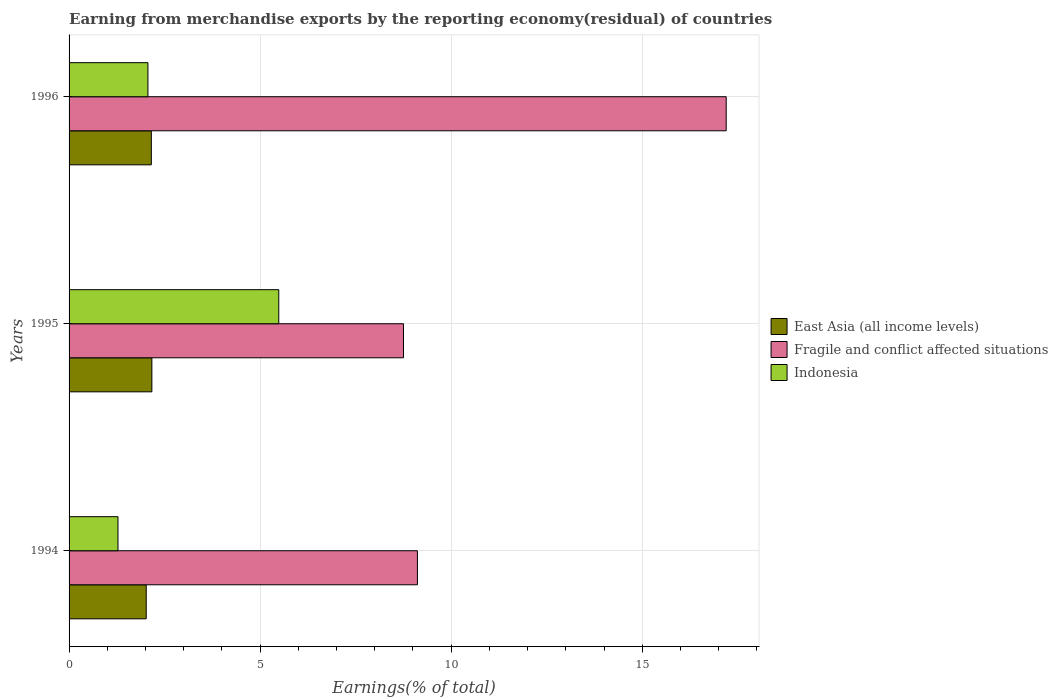How many groups of bars are there?
Make the answer very short. 3. Are the number of bars on each tick of the Y-axis equal?
Keep it short and to the point. Yes. How many bars are there on the 1st tick from the top?
Your answer should be compact. 3. How many bars are there on the 3rd tick from the bottom?
Make the answer very short. 3. What is the label of the 3rd group of bars from the top?
Provide a succinct answer. 1994. In how many cases, is the number of bars for a given year not equal to the number of legend labels?
Offer a very short reply. 0. What is the percentage of amount earned from merchandise exports in Indonesia in 1996?
Your answer should be compact. 2.06. Across all years, what is the maximum percentage of amount earned from merchandise exports in Fragile and conflict affected situations?
Your answer should be very brief. 17.2. Across all years, what is the minimum percentage of amount earned from merchandise exports in East Asia (all income levels)?
Provide a succinct answer. 2.02. In which year was the percentage of amount earned from merchandise exports in Fragile and conflict affected situations maximum?
Ensure brevity in your answer.  1996. What is the total percentage of amount earned from merchandise exports in East Asia (all income levels) in the graph?
Offer a very short reply. 6.34. What is the difference between the percentage of amount earned from merchandise exports in Fragile and conflict affected situations in 1995 and that in 1996?
Your response must be concise. -8.45. What is the difference between the percentage of amount earned from merchandise exports in Fragile and conflict affected situations in 1994 and the percentage of amount earned from merchandise exports in East Asia (all income levels) in 1995?
Offer a terse response. 6.95. What is the average percentage of amount earned from merchandise exports in Indonesia per year?
Your answer should be very brief. 2.94. In the year 1995, what is the difference between the percentage of amount earned from merchandise exports in East Asia (all income levels) and percentage of amount earned from merchandise exports in Fragile and conflict affected situations?
Provide a succinct answer. -6.59. What is the ratio of the percentage of amount earned from merchandise exports in East Asia (all income levels) in 1994 to that in 1996?
Make the answer very short. 0.94. Is the percentage of amount earned from merchandise exports in Fragile and conflict affected situations in 1994 less than that in 1995?
Offer a terse response. No. What is the difference between the highest and the second highest percentage of amount earned from merchandise exports in Indonesia?
Make the answer very short. 3.42. What is the difference between the highest and the lowest percentage of amount earned from merchandise exports in East Asia (all income levels)?
Your response must be concise. 0.15. In how many years, is the percentage of amount earned from merchandise exports in Fragile and conflict affected situations greater than the average percentage of amount earned from merchandise exports in Fragile and conflict affected situations taken over all years?
Keep it short and to the point. 1. What does the 2nd bar from the top in 1994 represents?
Provide a succinct answer. Fragile and conflict affected situations. What does the 1st bar from the bottom in 1995 represents?
Provide a succinct answer. East Asia (all income levels). How many bars are there?
Offer a very short reply. 9. Are the values on the major ticks of X-axis written in scientific E-notation?
Your response must be concise. No. Does the graph contain grids?
Provide a short and direct response. Yes. How many legend labels are there?
Your response must be concise. 3. What is the title of the graph?
Your answer should be very brief. Earning from merchandise exports by the reporting economy(residual) of countries. What is the label or title of the X-axis?
Offer a very short reply. Earnings(% of total). What is the Earnings(% of total) in East Asia (all income levels) in 1994?
Make the answer very short. 2.02. What is the Earnings(% of total) in Fragile and conflict affected situations in 1994?
Ensure brevity in your answer.  9.12. What is the Earnings(% of total) in Indonesia in 1994?
Provide a short and direct response. 1.28. What is the Earnings(% of total) of East Asia (all income levels) in 1995?
Give a very brief answer. 2.17. What is the Earnings(% of total) in Fragile and conflict affected situations in 1995?
Your response must be concise. 8.75. What is the Earnings(% of total) in Indonesia in 1995?
Provide a short and direct response. 5.49. What is the Earnings(% of total) in East Asia (all income levels) in 1996?
Offer a very short reply. 2.15. What is the Earnings(% of total) in Fragile and conflict affected situations in 1996?
Your answer should be compact. 17.2. What is the Earnings(% of total) in Indonesia in 1996?
Keep it short and to the point. 2.06. Across all years, what is the maximum Earnings(% of total) of East Asia (all income levels)?
Your answer should be compact. 2.17. Across all years, what is the maximum Earnings(% of total) of Fragile and conflict affected situations?
Offer a very short reply. 17.2. Across all years, what is the maximum Earnings(% of total) in Indonesia?
Keep it short and to the point. 5.49. Across all years, what is the minimum Earnings(% of total) of East Asia (all income levels)?
Make the answer very short. 2.02. Across all years, what is the minimum Earnings(% of total) in Fragile and conflict affected situations?
Make the answer very short. 8.75. Across all years, what is the minimum Earnings(% of total) in Indonesia?
Give a very brief answer. 1.28. What is the total Earnings(% of total) in East Asia (all income levels) in the graph?
Offer a very short reply. 6.34. What is the total Earnings(% of total) of Fragile and conflict affected situations in the graph?
Ensure brevity in your answer.  35.07. What is the total Earnings(% of total) of Indonesia in the graph?
Keep it short and to the point. 8.83. What is the difference between the Earnings(% of total) in East Asia (all income levels) in 1994 and that in 1995?
Ensure brevity in your answer.  -0.15. What is the difference between the Earnings(% of total) in Fragile and conflict affected situations in 1994 and that in 1995?
Offer a terse response. 0.36. What is the difference between the Earnings(% of total) of Indonesia in 1994 and that in 1995?
Offer a very short reply. -4.21. What is the difference between the Earnings(% of total) in East Asia (all income levels) in 1994 and that in 1996?
Keep it short and to the point. -0.13. What is the difference between the Earnings(% of total) of Fragile and conflict affected situations in 1994 and that in 1996?
Give a very brief answer. -8.08. What is the difference between the Earnings(% of total) in Indonesia in 1994 and that in 1996?
Keep it short and to the point. -0.78. What is the difference between the Earnings(% of total) in East Asia (all income levels) in 1995 and that in 1996?
Your answer should be very brief. 0.01. What is the difference between the Earnings(% of total) of Fragile and conflict affected situations in 1995 and that in 1996?
Your answer should be compact. -8.45. What is the difference between the Earnings(% of total) of Indonesia in 1995 and that in 1996?
Provide a succinct answer. 3.42. What is the difference between the Earnings(% of total) of East Asia (all income levels) in 1994 and the Earnings(% of total) of Fragile and conflict affected situations in 1995?
Make the answer very short. -6.73. What is the difference between the Earnings(% of total) in East Asia (all income levels) in 1994 and the Earnings(% of total) in Indonesia in 1995?
Your answer should be very brief. -3.47. What is the difference between the Earnings(% of total) in Fragile and conflict affected situations in 1994 and the Earnings(% of total) in Indonesia in 1995?
Your answer should be very brief. 3.63. What is the difference between the Earnings(% of total) of East Asia (all income levels) in 1994 and the Earnings(% of total) of Fragile and conflict affected situations in 1996?
Provide a succinct answer. -15.18. What is the difference between the Earnings(% of total) in East Asia (all income levels) in 1994 and the Earnings(% of total) in Indonesia in 1996?
Ensure brevity in your answer.  -0.04. What is the difference between the Earnings(% of total) of Fragile and conflict affected situations in 1994 and the Earnings(% of total) of Indonesia in 1996?
Offer a very short reply. 7.05. What is the difference between the Earnings(% of total) of East Asia (all income levels) in 1995 and the Earnings(% of total) of Fragile and conflict affected situations in 1996?
Your answer should be very brief. -15.03. What is the difference between the Earnings(% of total) of East Asia (all income levels) in 1995 and the Earnings(% of total) of Indonesia in 1996?
Offer a very short reply. 0.1. What is the difference between the Earnings(% of total) in Fragile and conflict affected situations in 1995 and the Earnings(% of total) in Indonesia in 1996?
Provide a short and direct response. 6.69. What is the average Earnings(% of total) in East Asia (all income levels) per year?
Give a very brief answer. 2.11. What is the average Earnings(% of total) in Fragile and conflict affected situations per year?
Your answer should be compact. 11.69. What is the average Earnings(% of total) in Indonesia per year?
Your answer should be compact. 2.94. In the year 1994, what is the difference between the Earnings(% of total) in East Asia (all income levels) and Earnings(% of total) in Fragile and conflict affected situations?
Ensure brevity in your answer.  -7.1. In the year 1994, what is the difference between the Earnings(% of total) in East Asia (all income levels) and Earnings(% of total) in Indonesia?
Offer a terse response. 0.74. In the year 1994, what is the difference between the Earnings(% of total) of Fragile and conflict affected situations and Earnings(% of total) of Indonesia?
Provide a succinct answer. 7.84. In the year 1995, what is the difference between the Earnings(% of total) in East Asia (all income levels) and Earnings(% of total) in Fragile and conflict affected situations?
Make the answer very short. -6.59. In the year 1995, what is the difference between the Earnings(% of total) of East Asia (all income levels) and Earnings(% of total) of Indonesia?
Ensure brevity in your answer.  -3.32. In the year 1995, what is the difference between the Earnings(% of total) in Fragile and conflict affected situations and Earnings(% of total) in Indonesia?
Give a very brief answer. 3.26. In the year 1996, what is the difference between the Earnings(% of total) of East Asia (all income levels) and Earnings(% of total) of Fragile and conflict affected situations?
Make the answer very short. -15.04. In the year 1996, what is the difference between the Earnings(% of total) of East Asia (all income levels) and Earnings(% of total) of Indonesia?
Offer a very short reply. 0.09. In the year 1996, what is the difference between the Earnings(% of total) of Fragile and conflict affected situations and Earnings(% of total) of Indonesia?
Provide a succinct answer. 15.13. What is the ratio of the Earnings(% of total) of East Asia (all income levels) in 1994 to that in 1995?
Your answer should be very brief. 0.93. What is the ratio of the Earnings(% of total) in Fragile and conflict affected situations in 1994 to that in 1995?
Offer a very short reply. 1.04. What is the ratio of the Earnings(% of total) in Indonesia in 1994 to that in 1995?
Offer a very short reply. 0.23. What is the ratio of the Earnings(% of total) in East Asia (all income levels) in 1994 to that in 1996?
Keep it short and to the point. 0.94. What is the ratio of the Earnings(% of total) in Fragile and conflict affected situations in 1994 to that in 1996?
Make the answer very short. 0.53. What is the ratio of the Earnings(% of total) of Indonesia in 1994 to that in 1996?
Make the answer very short. 0.62. What is the ratio of the Earnings(% of total) of East Asia (all income levels) in 1995 to that in 1996?
Your answer should be very brief. 1.01. What is the ratio of the Earnings(% of total) of Fragile and conflict affected situations in 1995 to that in 1996?
Provide a short and direct response. 0.51. What is the ratio of the Earnings(% of total) in Indonesia in 1995 to that in 1996?
Offer a very short reply. 2.66. What is the difference between the highest and the second highest Earnings(% of total) in East Asia (all income levels)?
Give a very brief answer. 0.01. What is the difference between the highest and the second highest Earnings(% of total) in Fragile and conflict affected situations?
Offer a very short reply. 8.08. What is the difference between the highest and the second highest Earnings(% of total) in Indonesia?
Ensure brevity in your answer.  3.42. What is the difference between the highest and the lowest Earnings(% of total) in East Asia (all income levels)?
Your answer should be very brief. 0.15. What is the difference between the highest and the lowest Earnings(% of total) in Fragile and conflict affected situations?
Your answer should be compact. 8.45. What is the difference between the highest and the lowest Earnings(% of total) of Indonesia?
Ensure brevity in your answer.  4.21. 